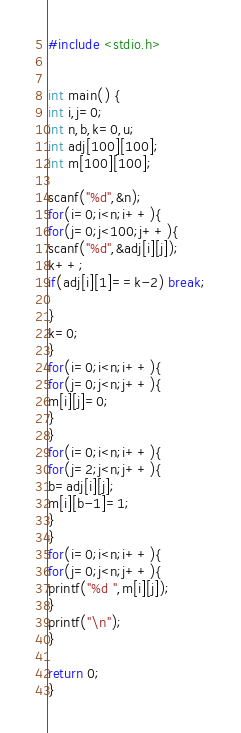<code> <loc_0><loc_0><loc_500><loc_500><_C_>#include <stdio.h>


int main() {
int i,j=0;
int n,b,k=0,u;
int adj[100][100];
int m[100][100];

scanf("%d",&n);
for(i=0;i<n;i++){
for(j=0;j<100;j++){
scanf("%d",&adj[i][j]);
k++;
if(adj[i][1]==k-2) break;
      
}
k=0;
}
for(i=0;i<n;i++){
for(j=0;j<n;j++){
m[i][j]=0;
}
}
for(i=0;i<n;i++){
for(j=2;j<n;j++){
b=adj[i][j];
m[i][b-1]=1;
}
}
for(i=0;i<n;i++){
for(j=0;j<n;j++){
printf("%d ",m[i][j]);
}
printf("\n");
}
  
return 0;
}</code> 